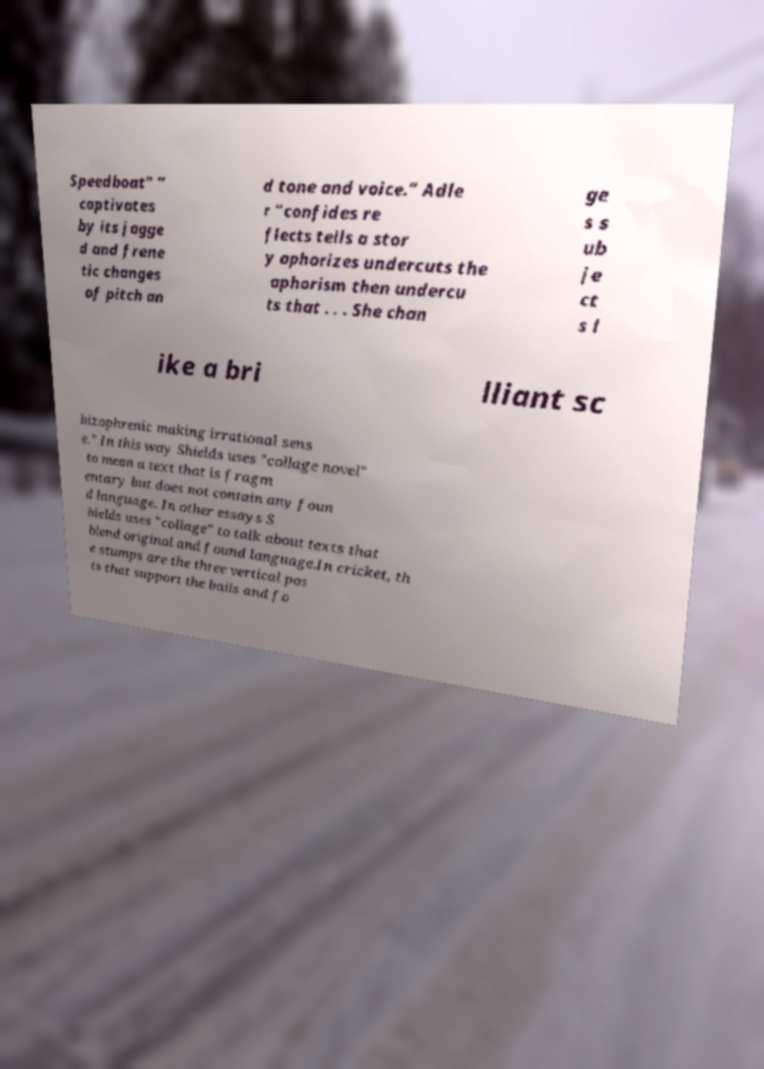What messages or text are displayed in this image? I need them in a readable, typed format. Speedboat" “ captivates by its jagge d and frene tic changes of pitch an d tone and voice.” Adle r “confides re flects tells a stor y aphorizes undercuts the aphorism then undercu ts that . . . She chan ge s s ub je ct s l ike a bri lliant sc hizophrenic making irrational sens e.” In this way Shields uses "collage novel" to mean a text that is fragm entary but does not contain any foun d language. In other essays S hields uses "collage" to talk about texts that blend original and found language.In cricket, th e stumps are the three vertical pos ts that support the bails and fo 